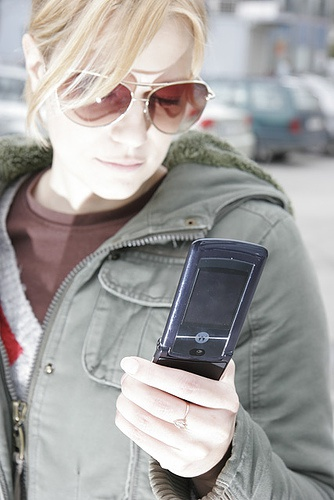Describe the objects in this image and their specific colors. I can see people in lightgray, darkgray, gray, and black tones, cell phone in darkgray, gray, and black tones, car in darkgray, gray, and lightgray tones, car in darkgray and lightgray tones, and car in darkgray and lightgray tones in this image. 